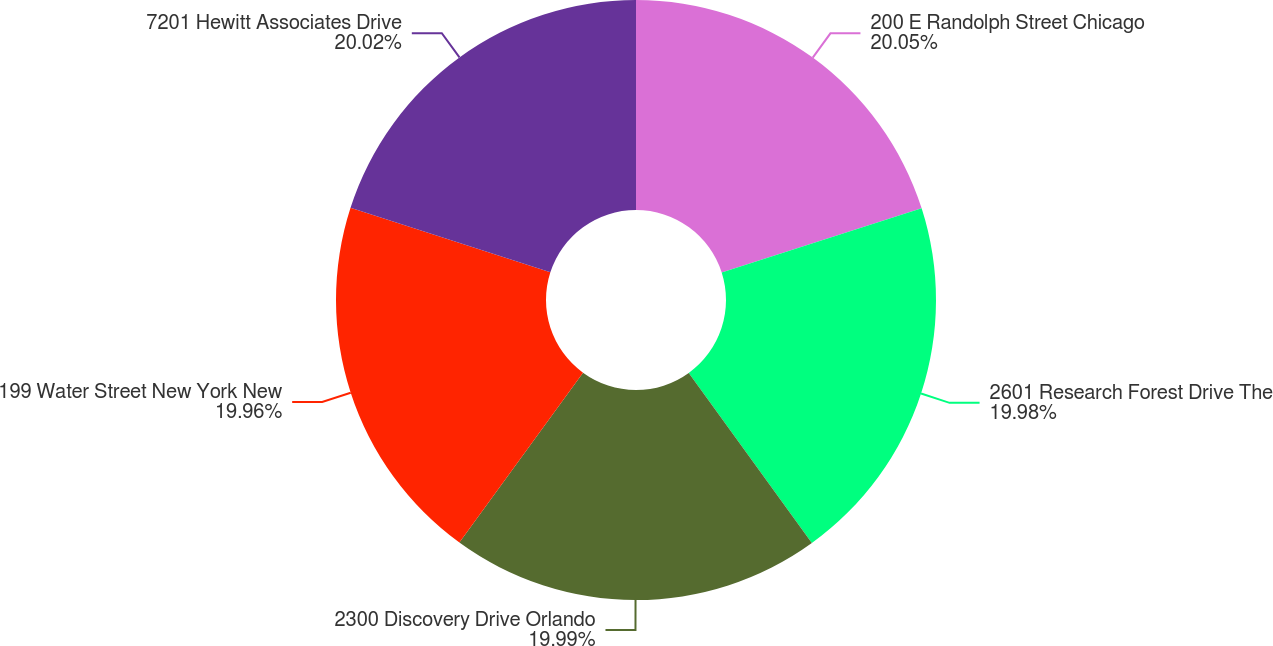Convert chart to OTSL. <chart><loc_0><loc_0><loc_500><loc_500><pie_chart><fcel>200 E Randolph Street Chicago<fcel>2601 Research Forest Drive The<fcel>2300 Discovery Drive Orlando<fcel>199 Water Street New York New<fcel>7201 Hewitt Associates Drive<nl><fcel>20.06%<fcel>19.98%<fcel>19.99%<fcel>19.96%<fcel>20.03%<nl></chart> 